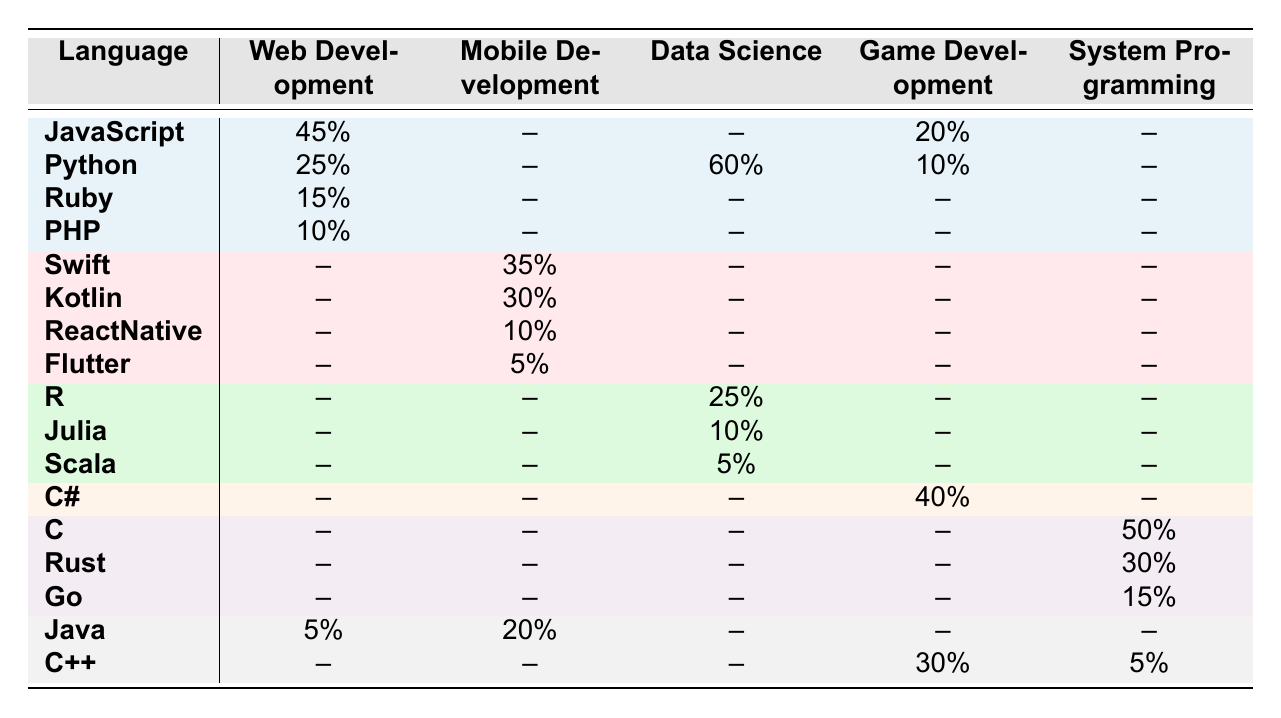What is the percentage of JavaScript usage in Web Development? The table indicates that JavaScript usage in Web Development is 45%. This can be read directly from the Web Development column under JavaScript.
Answer: 45% Which programming language is used the least in Mobile Development? In the Mobile Development column, the lowest value is 5%, which corresponds to Flutter. This is the only entry with the lowest percentage when compared to others in that column.
Answer: Flutter What is the total percentage of Python usage across all project types? To find the total percentage of Python usage, we need to add its percentages from different project types: 25% (Web Development) + 60% (Data Science) + 10% (Game Development) = 95%.
Answer: 95% Does any programming language have a higher usage in Data Science than in Game Development? Yes, Python has a usage of 60% in Data Science, while its usage in Game Development is only 10%. According to the table, no other language matches or exceeds this value when comparing the two categories.
Answer: Yes What is the average percentage of usage for System Programming languages listed in the table? The System Programming languages listed are C (50%), Rust (30%), Go (15%), and C++ (5%). Adding these values: 50% + 30% + 15% + 5% = 100%. The average is then calculated by dividing the total by the number of languages (4): 100% / 4 = 25%.
Answer: 25% Which project type has the highest percentage of languages usage overall? To determine this, we compare the total percentages for each project type based on the languages used. Web Development has 95% (45% + 25% + 15% +10% + 5%), Mobile Development has 100% (35% + 30% + 20% + 10% + 5%), Data Science has 100% (60% + 25% + 10% + 5%), Game Development has 100% (40% + 20% + 10%), and System Programming has 100% (50% + 30% + 15% + 5%). Thus, all except Web Development have the highest percentage at 100%.
Answer: Mobile Development, Data Science, Game Development, System Programming Is there a programming language that appears in both Data Science and Game Development? Upon reviewing the table, Python is listed under both Data Science (60%) and Game Development (10%). Thus, this is indeed a language that is shared across these two project types.
Answer: Yes 